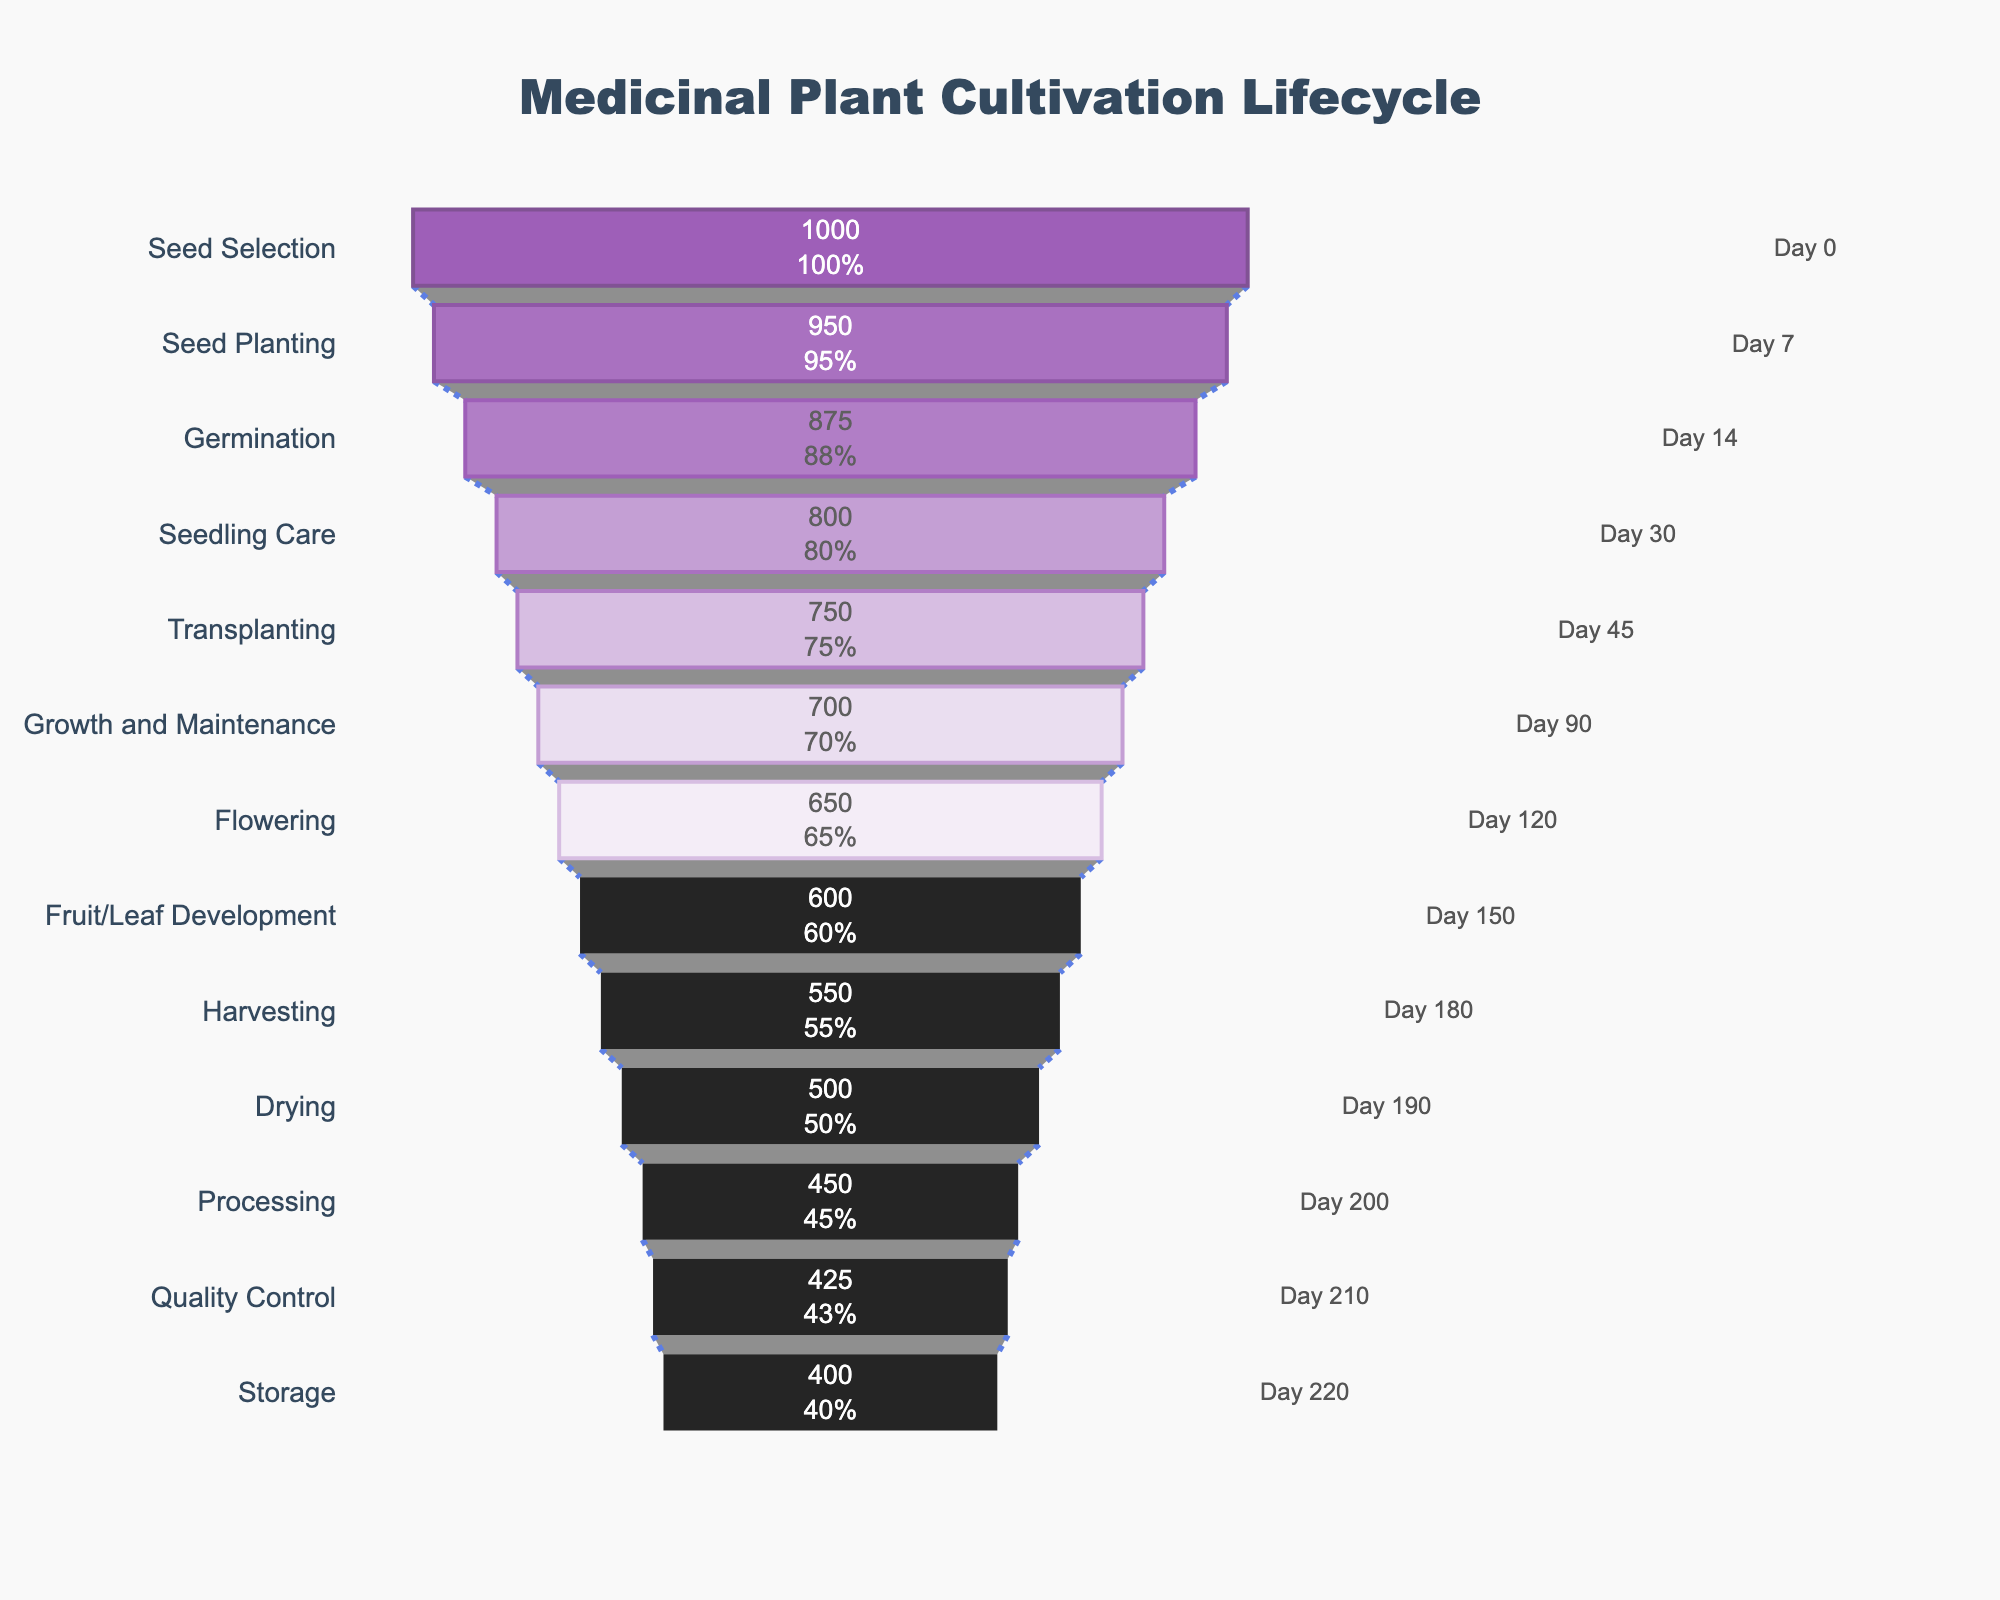what is the title of the figure? The title is displayed at the top center of the figure and it reads "Medicinal Plant Cultivation Lifecycle". You can see it clearly because it's in a larger font size and different style.
Answer: Medicinal Plant Cultivation Lifecycle what stage occurs after Germination? The figure shows the stages in a sequential order from top to bottom. The stage listed immediately after Germination is Seedling Care.
Answer: Seedling Care at what stage do we have 750 plants remaining? By looking at the number of plants remaining and matching it to the corresponding stage, we can see that Transplanting has 750 plants remaining.
Answer: Transplanting what is the percentage drop in plants from Seed Selection to Seed Planting? Seed Selection has 1000 plants and Seed Planting has 950. The decrease in plants is 1000 - 950 = 50. The percentage drop is (50/1000) * 100% = 5%.
Answer: 5% how many stages take place before Harvesting? By counting the stages from the top until Harvesting, we see Seed Selection, Seed Planting, Germination, Seedling Care, Transplanting, Growth and Maintenance, Flowering, Fruit/Leaf Development. That's 8 stages.
Answer: 8 stages in which two stages do we have the same number of plants remaining? Looking through the figure, we notice that there are no stages with the exact same number of plants remaining. Each stage has a unique number of plants.
Answer: None how many days are there between Seedling Care and Flowering? Seedling Care occurs at day 30 and Flowering at day 120. Subtracting these gives 120 - 30 = 90 days between these stages.
Answer: 90 days how many days in total does the entire lifecycle take? The lifecycle starts at day 0 and ends at day 220. Subtracting these gives a total of 220 days.
Answer: 220 days 